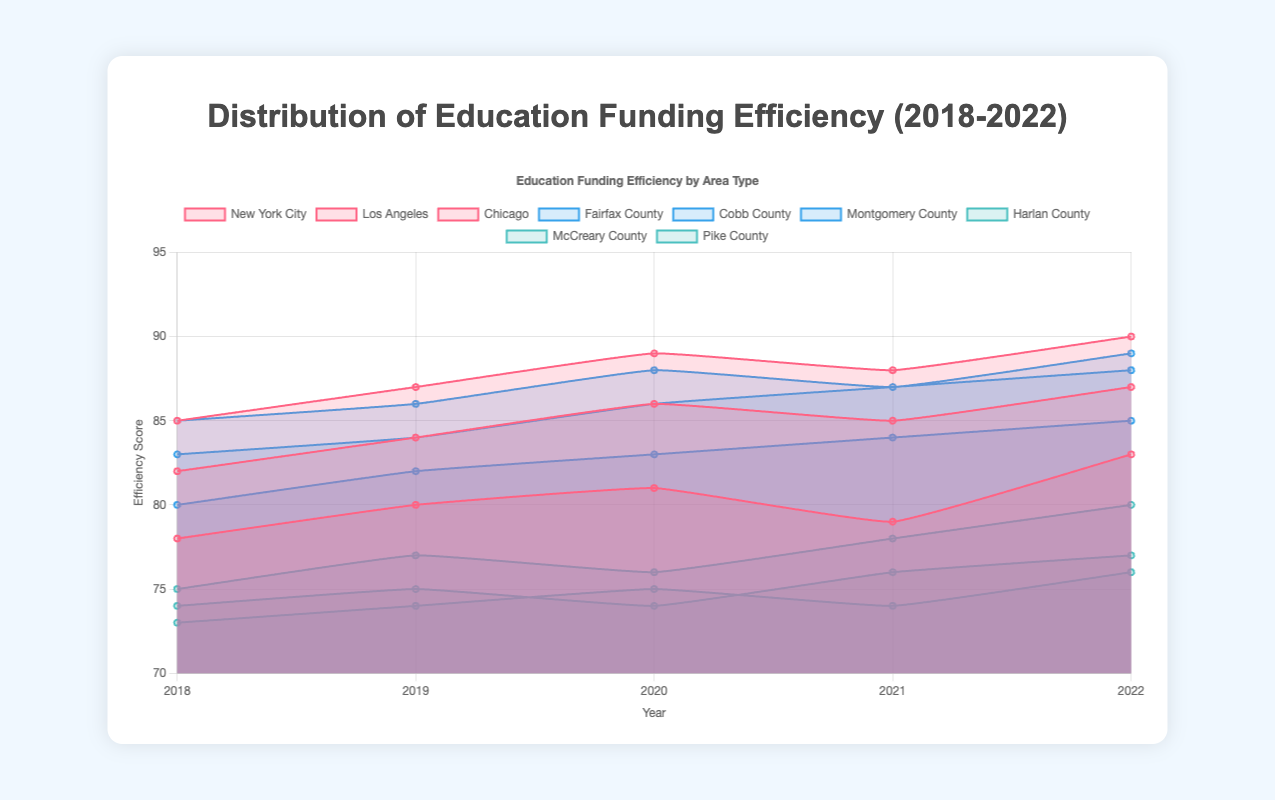How many years of data are displayed in the chart? The x-axis labels indicate the years shown in the chart. Between 2018 and 2022, there are five distinct years displayed.
Answer: 5 Which school type had the highest efficiency score in 2022? The highest efficiency score is marked by the topmost point on the y-axis in 2022. Urban schools (New York City) have the highest score of 90 in 2022.
Answer: Urban (New York City) What is the efficiency score trend for Chicago's urban schools from 2018 to 2022? By looking at Chicago's data points across the years, the scores increase mostly, with some fluctuations, starting at 78 in 2018 and reaching 83 in 2022.
Answer: Increasing trend with fluctuations Which suburban school had the lowest efficiency score in 2018? Among the suburban schools, Cobb County shows the lowest efficiency score, which can be read from the y-axis intersection in 2018 at 80.
Answer: Cobb County How much did efficiency scores improve in Montgomery County suburban schools from 2018 to 2022? The efficiency score for Montgomery County in 2018 is 85 and in 2022 is 89. The improvement is calculated as 89 - 85 = 4.
Answer: 4 Compare the efficiency scores of Harlan County and McCreary County rural schools in 2021. Which one was higher? By comparing the data points for both counties in 2021 on the y-axis, Harlan County’s score is 78 while McCreary County’s score is 76. Hence, Harlan County has a higher score.
Answer: Harlan County Which school type shows the smallest variation in efficiency scores over the given period? By examining the range of efficiency scores for each school type, suburban schools show the smallest variation with entries mostly close together.
Answer: Suburban During which year did New York City urban schools experience a decline in efficiency score? By following New York City's data points from year to year, the efficiency score declined from 2019 (87) to 2021 (88).
Answer: 2020 to 2021 What is the average efficiency score for suburban schools in 2020? Summing the 2020 scores of Fairfax (86), Cobb (83), and Montgomery (88) counties, then dividing by 3, gives (86 + 83 + 88) / 3 = 85.67.
Answer: 85.67 